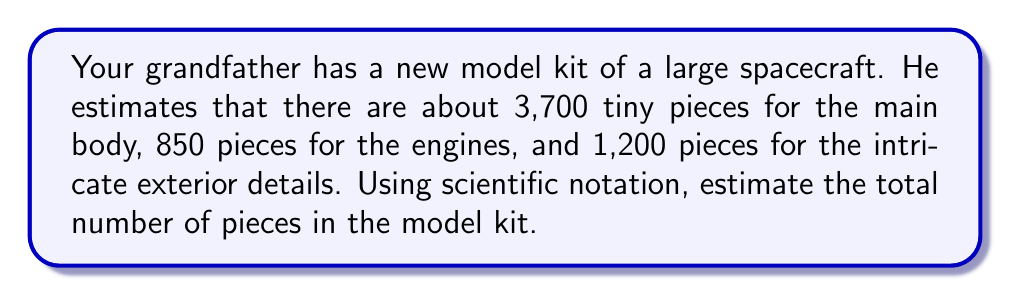Solve this math problem. Let's approach this step-by-step:

1) First, we need to add up all the pieces:
   Main body: 3,700
   Engines: 850
   Exterior details: 1,200

   Total = 3,700 + 850 + 1,200 = 5,750

2) Now, we need to express this in scientific notation. In scientific notation, a number is expressed as:

   $a \times 10^n$

   Where $1 \leq |a| < 10$ and $n$ is an integer.

3) To convert 5,750 to scientific notation:
   
   5,750 = 5.75 × 1,000 = 5.75 × $10^3$

4) Therefore, the estimated number of pieces in scientific notation is:

   $5.75 \times 10^3$

This notation tells us that the decimal point in 5.75 needs to be moved 3 places to the right to get the original number.
Answer: $5.75 \times 10^3$ pieces 